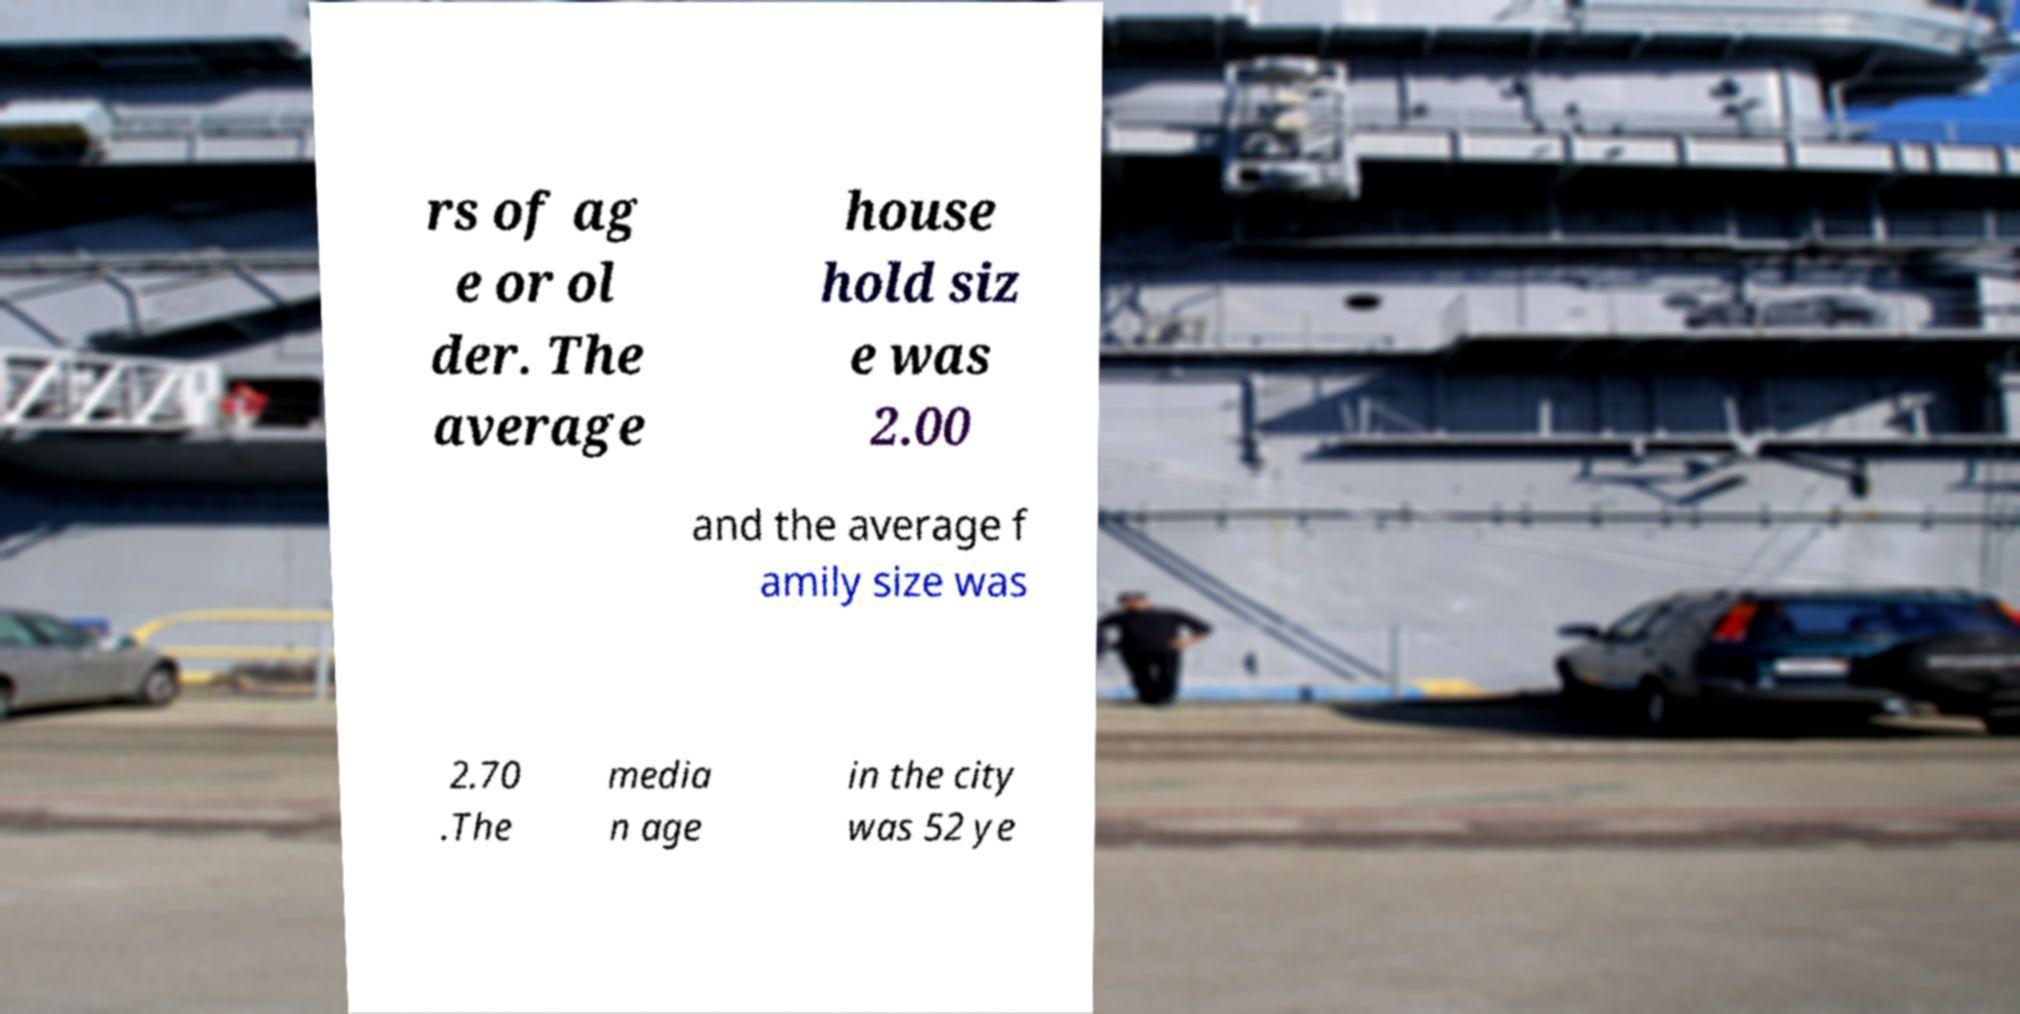Can you accurately transcribe the text from the provided image for me? rs of ag e or ol der. The average house hold siz e was 2.00 and the average f amily size was 2.70 .The media n age in the city was 52 ye 